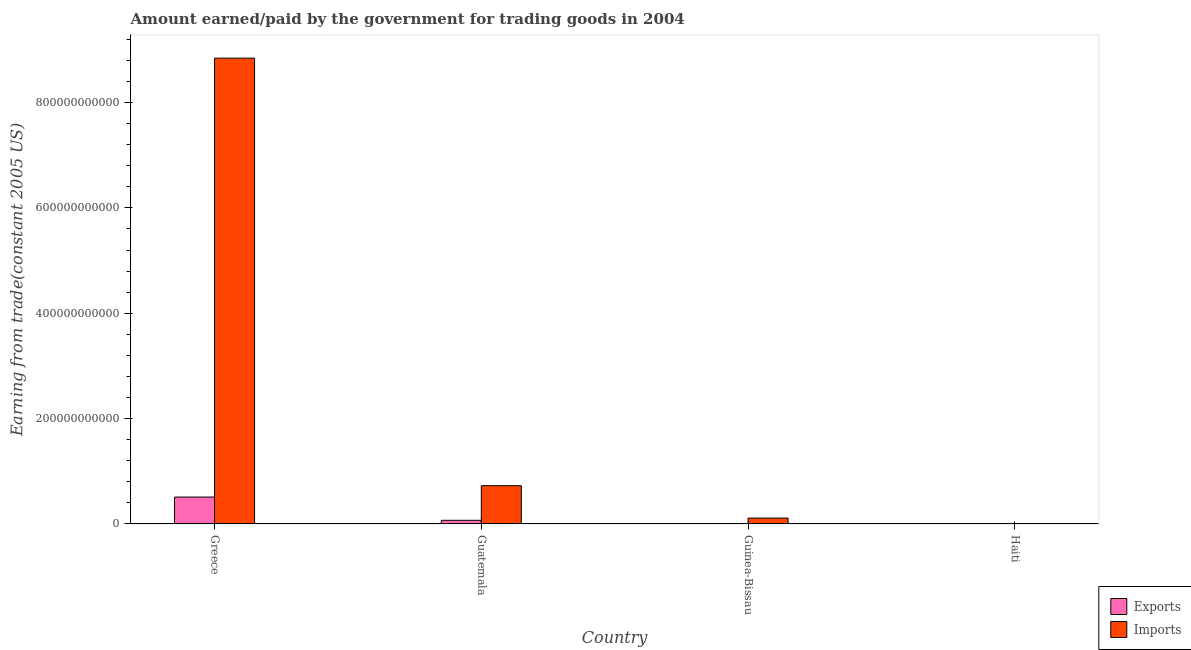How many different coloured bars are there?
Your answer should be compact. 2. Are the number of bars per tick equal to the number of legend labels?
Keep it short and to the point. Yes. Are the number of bars on each tick of the X-axis equal?
Your answer should be very brief. Yes. How many bars are there on the 1st tick from the right?
Make the answer very short. 2. What is the label of the 2nd group of bars from the left?
Ensure brevity in your answer.  Guatemala. What is the amount earned from exports in Guatemala?
Keep it short and to the point. 6.96e+09. Across all countries, what is the maximum amount paid for imports?
Provide a succinct answer. 8.84e+11. Across all countries, what is the minimum amount paid for imports?
Your answer should be very brief. 1.71e+08. In which country was the amount earned from exports maximum?
Keep it short and to the point. Greece. In which country was the amount paid for imports minimum?
Your response must be concise. Haiti. What is the total amount paid for imports in the graph?
Give a very brief answer. 9.68e+11. What is the difference between the amount paid for imports in Guinea-Bissau and that in Haiti?
Keep it short and to the point. 1.10e+1. What is the difference between the amount earned from exports in Guinea-Bissau and the amount paid for imports in Guatemala?
Make the answer very short. -7.26e+1. What is the average amount paid for imports per country?
Offer a terse response. 2.42e+11. What is the difference between the amount paid for imports and amount earned from exports in Guinea-Bissau?
Give a very brief answer. 1.11e+1. What is the ratio of the amount paid for imports in Guatemala to that in Guinea-Bissau?
Make the answer very short. 6.48. Is the amount paid for imports in Guatemala less than that in Haiti?
Make the answer very short. No. What is the difference between the highest and the second highest amount earned from exports?
Offer a very short reply. 4.41e+1. What is the difference between the highest and the lowest amount earned from exports?
Your response must be concise. 5.10e+1. What does the 1st bar from the left in Guatemala represents?
Your response must be concise. Exports. What does the 1st bar from the right in Greece represents?
Your answer should be very brief. Imports. Are all the bars in the graph horizontal?
Offer a terse response. No. What is the difference between two consecutive major ticks on the Y-axis?
Make the answer very short. 2.00e+11. Does the graph contain any zero values?
Your answer should be very brief. No. Does the graph contain grids?
Offer a terse response. No. How many legend labels are there?
Provide a short and direct response. 2. How are the legend labels stacked?
Provide a succinct answer. Vertical. What is the title of the graph?
Your answer should be compact. Amount earned/paid by the government for trading goods in 2004. Does "GDP per capita" appear as one of the legend labels in the graph?
Make the answer very short. No. What is the label or title of the Y-axis?
Provide a short and direct response. Earning from trade(constant 2005 US). What is the Earning from trade(constant 2005 US) in Exports in Greece?
Your answer should be compact. 5.11e+1. What is the Earning from trade(constant 2005 US) in Imports in Greece?
Provide a succinct answer. 8.84e+11. What is the Earning from trade(constant 2005 US) of Exports in Guatemala?
Your answer should be compact. 6.96e+09. What is the Earning from trade(constant 2005 US) in Imports in Guatemala?
Offer a terse response. 7.27e+1. What is the Earning from trade(constant 2005 US) in Exports in Guinea-Bissau?
Offer a terse response. 8.50e+07. What is the Earning from trade(constant 2005 US) of Imports in Guinea-Bissau?
Make the answer very short. 1.12e+1. What is the Earning from trade(constant 2005 US) in Exports in Haiti?
Make the answer very short. 6.05e+08. What is the Earning from trade(constant 2005 US) of Imports in Haiti?
Provide a short and direct response. 1.71e+08. Across all countries, what is the maximum Earning from trade(constant 2005 US) of Exports?
Keep it short and to the point. 5.11e+1. Across all countries, what is the maximum Earning from trade(constant 2005 US) in Imports?
Your response must be concise. 8.84e+11. Across all countries, what is the minimum Earning from trade(constant 2005 US) in Exports?
Provide a short and direct response. 8.50e+07. Across all countries, what is the minimum Earning from trade(constant 2005 US) of Imports?
Your response must be concise. 1.71e+08. What is the total Earning from trade(constant 2005 US) of Exports in the graph?
Your response must be concise. 5.88e+1. What is the total Earning from trade(constant 2005 US) of Imports in the graph?
Keep it short and to the point. 9.68e+11. What is the difference between the Earning from trade(constant 2005 US) of Exports in Greece and that in Guatemala?
Ensure brevity in your answer.  4.41e+1. What is the difference between the Earning from trade(constant 2005 US) in Imports in Greece and that in Guatemala?
Make the answer very short. 8.11e+11. What is the difference between the Earning from trade(constant 2005 US) in Exports in Greece and that in Guinea-Bissau?
Provide a succinct answer. 5.10e+1. What is the difference between the Earning from trade(constant 2005 US) in Imports in Greece and that in Guinea-Bissau?
Your answer should be compact. 8.73e+11. What is the difference between the Earning from trade(constant 2005 US) in Exports in Greece and that in Haiti?
Make the answer very short. 5.05e+1. What is the difference between the Earning from trade(constant 2005 US) in Imports in Greece and that in Haiti?
Keep it short and to the point. 8.84e+11. What is the difference between the Earning from trade(constant 2005 US) of Exports in Guatemala and that in Guinea-Bissau?
Offer a very short reply. 6.88e+09. What is the difference between the Earning from trade(constant 2005 US) in Imports in Guatemala and that in Guinea-Bissau?
Keep it short and to the point. 6.15e+1. What is the difference between the Earning from trade(constant 2005 US) in Exports in Guatemala and that in Haiti?
Give a very brief answer. 6.36e+09. What is the difference between the Earning from trade(constant 2005 US) of Imports in Guatemala and that in Haiti?
Provide a succinct answer. 7.25e+1. What is the difference between the Earning from trade(constant 2005 US) in Exports in Guinea-Bissau and that in Haiti?
Ensure brevity in your answer.  -5.20e+08. What is the difference between the Earning from trade(constant 2005 US) in Imports in Guinea-Bissau and that in Haiti?
Offer a terse response. 1.10e+1. What is the difference between the Earning from trade(constant 2005 US) in Exports in Greece and the Earning from trade(constant 2005 US) in Imports in Guatemala?
Your answer should be very brief. -2.16e+1. What is the difference between the Earning from trade(constant 2005 US) in Exports in Greece and the Earning from trade(constant 2005 US) in Imports in Guinea-Bissau?
Offer a very short reply. 3.99e+1. What is the difference between the Earning from trade(constant 2005 US) in Exports in Greece and the Earning from trade(constant 2005 US) in Imports in Haiti?
Make the answer very short. 5.09e+1. What is the difference between the Earning from trade(constant 2005 US) in Exports in Guatemala and the Earning from trade(constant 2005 US) in Imports in Guinea-Bissau?
Offer a very short reply. -4.25e+09. What is the difference between the Earning from trade(constant 2005 US) of Exports in Guatemala and the Earning from trade(constant 2005 US) of Imports in Haiti?
Your answer should be compact. 6.79e+09. What is the difference between the Earning from trade(constant 2005 US) of Exports in Guinea-Bissau and the Earning from trade(constant 2005 US) of Imports in Haiti?
Keep it short and to the point. -8.57e+07. What is the average Earning from trade(constant 2005 US) of Exports per country?
Offer a very short reply. 1.47e+1. What is the average Earning from trade(constant 2005 US) of Imports per country?
Offer a terse response. 2.42e+11. What is the difference between the Earning from trade(constant 2005 US) of Exports and Earning from trade(constant 2005 US) of Imports in Greece?
Keep it short and to the point. -8.33e+11. What is the difference between the Earning from trade(constant 2005 US) of Exports and Earning from trade(constant 2005 US) of Imports in Guatemala?
Offer a terse response. -6.57e+1. What is the difference between the Earning from trade(constant 2005 US) of Exports and Earning from trade(constant 2005 US) of Imports in Guinea-Bissau?
Your response must be concise. -1.11e+1. What is the difference between the Earning from trade(constant 2005 US) of Exports and Earning from trade(constant 2005 US) of Imports in Haiti?
Give a very brief answer. 4.34e+08. What is the ratio of the Earning from trade(constant 2005 US) in Exports in Greece to that in Guatemala?
Make the answer very short. 7.34. What is the ratio of the Earning from trade(constant 2005 US) of Imports in Greece to that in Guatemala?
Your answer should be very brief. 12.16. What is the ratio of the Earning from trade(constant 2005 US) of Exports in Greece to that in Guinea-Bissau?
Provide a succinct answer. 601.5. What is the ratio of the Earning from trade(constant 2005 US) of Imports in Greece to that in Guinea-Bissau?
Provide a short and direct response. 78.8. What is the ratio of the Earning from trade(constant 2005 US) of Exports in Greece to that in Haiti?
Your answer should be compact. 84.47. What is the ratio of the Earning from trade(constant 2005 US) in Imports in Greece to that in Haiti?
Your response must be concise. 5180.7. What is the ratio of the Earning from trade(constant 2005 US) in Exports in Guatemala to that in Guinea-Bissau?
Make the answer very short. 81.98. What is the ratio of the Earning from trade(constant 2005 US) in Imports in Guatemala to that in Guinea-Bissau?
Your response must be concise. 6.48. What is the ratio of the Earning from trade(constant 2005 US) in Exports in Guatemala to that in Haiti?
Offer a terse response. 11.51. What is the ratio of the Earning from trade(constant 2005 US) in Imports in Guatemala to that in Haiti?
Your answer should be very brief. 425.97. What is the ratio of the Earning from trade(constant 2005 US) of Exports in Guinea-Bissau to that in Haiti?
Your answer should be compact. 0.14. What is the ratio of the Earning from trade(constant 2005 US) of Imports in Guinea-Bissau to that in Haiti?
Provide a succinct answer. 65.74. What is the difference between the highest and the second highest Earning from trade(constant 2005 US) of Exports?
Keep it short and to the point. 4.41e+1. What is the difference between the highest and the second highest Earning from trade(constant 2005 US) in Imports?
Offer a terse response. 8.11e+11. What is the difference between the highest and the lowest Earning from trade(constant 2005 US) of Exports?
Offer a very short reply. 5.10e+1. What is the difference between the highest and the lowest Earning from trade(constant 2005 US) in Imports?
Provide a short and direct response. 8.84e+11. 